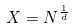<formula> <loc_0><loc_0><loc_500><loc_500>X = N ^ { \frac { 1 } { d } }</formula> 